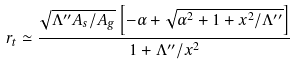Convert formula to latex. <formula><loc_0><loc_0><loc_500><loc_500>r _ { t } \simeq \frac { \sqrt { \Lambda ^ { \prime \prime } A _ { s } / A _ { g } } \left [ - \alpha + \sqrt { \alpha ^ { 2 } + 1 + x ^ { 2 } / \Lambda ^ { \prime \prime } } \right ] } { 1 + \Lambda ^ { \prime \prime } / x ^ { 2 } }</formula> 